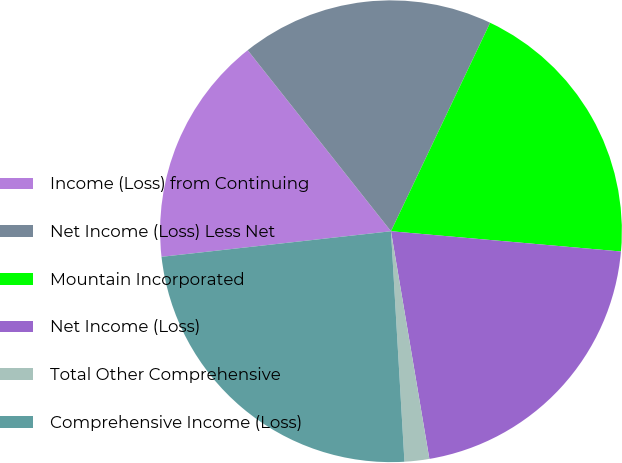Convert chart. <chart><loc_0><loc_0><loc_500><loc_500><pie_chart><fcel>Income (Loss) from Continuing<fcel>Net Income (Loss) Less Net<fcel>Mountain Incorporated<fcel>Net Income (Loss)<fcel>Total Other Comprehensive<fcel>Comprehensive Income (Loss)<nl><fcel>16.11%<fcel>17.72%<fcel>19.33%<fcel>20.94%<fcel>1.73%<fcel>24.16%<nl></chart> 